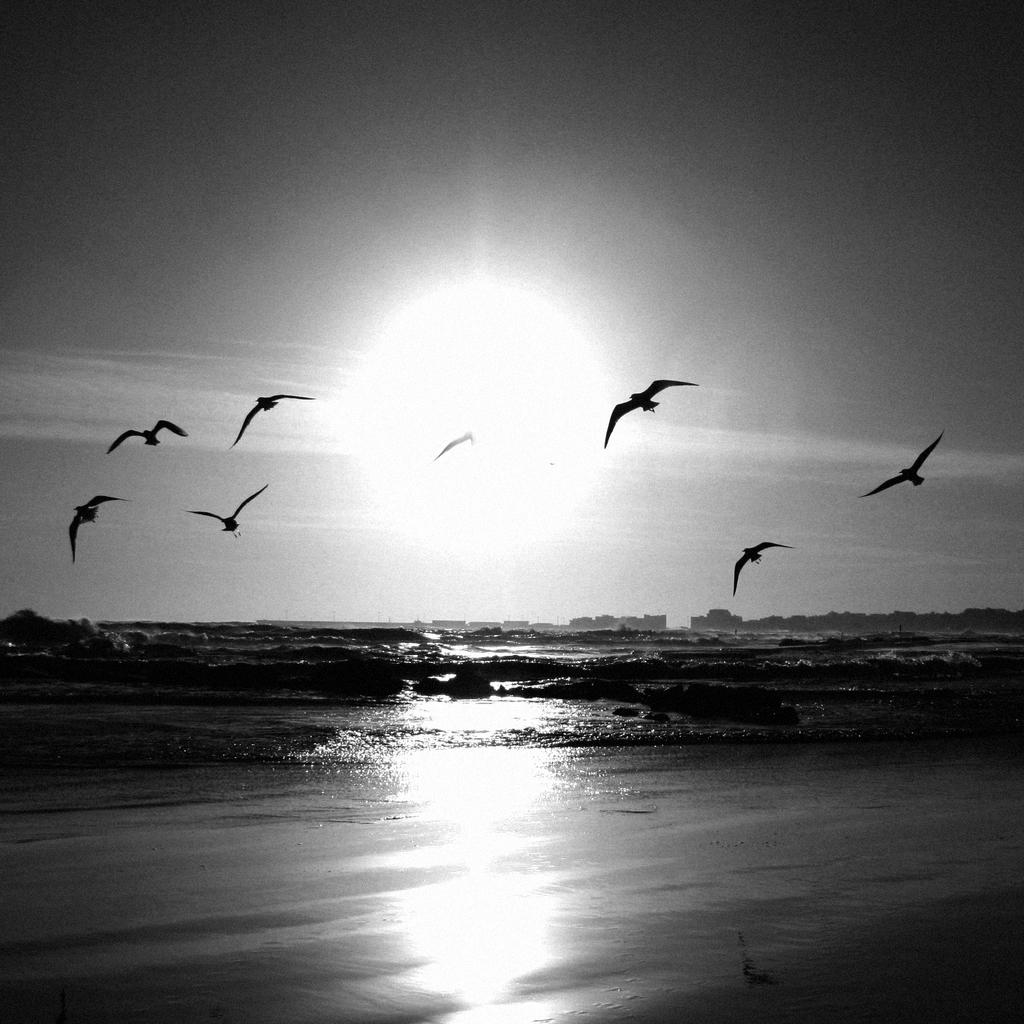What is the primary element in the image? There is water in the image. What can be seen in the background of the image? Birds are flying in the background of the image, and the sky is also visible. How is the image presented in terms of color? The image is in black and white. What type of whistle can be heard in the image? There is no whistle present in the image, as it is a visual representation and does not include sound. 